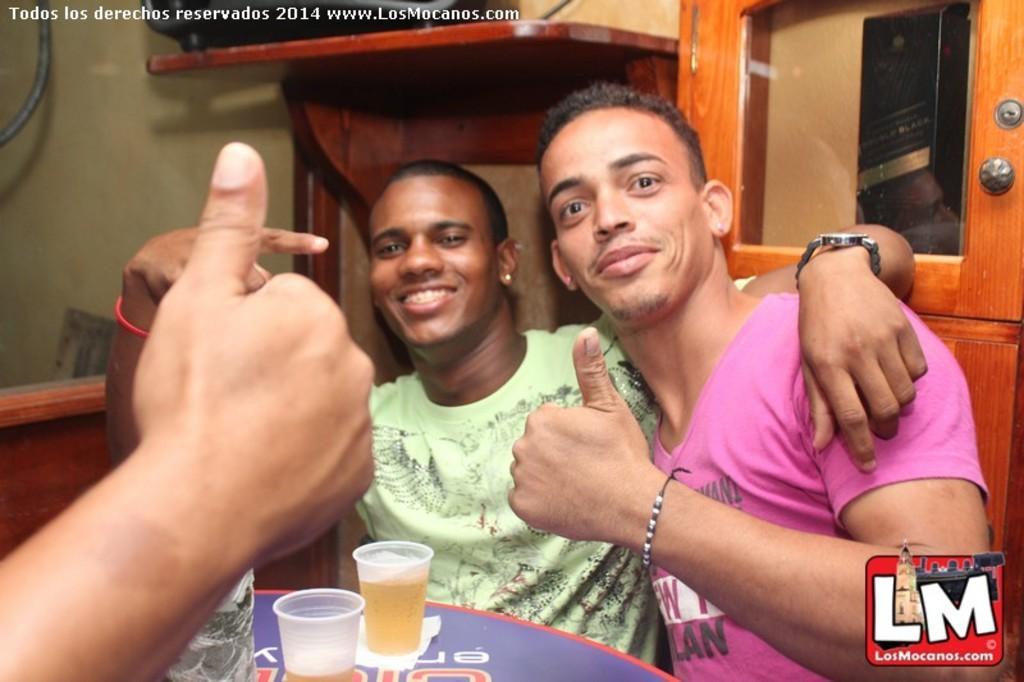Describe this image in one or two sentences. In this picture there are two friends sitting on the chair, Smiling and giving pose into the photograph. In the front table there are two wine glasses. In the background there is a wooden wardrobe door and green wall. 